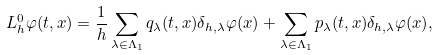Convert formula to latex. <formula><loc_0><loc_0><loc_500><loc_500>L _ { h } ^ { 0 } \varphi ( t , x ) = \frac { 1 } { h } \sum _ { \lambda \in \Lambda _ { 1 } } q _ { \lambda } ( t , x ) \delta _ { h , \lambda } \varphi ( x ) + \sum _ { \lambda \in \Lambda _ { 1 } } p _ { \lambda } ( t , x ) \delta _ { h , \lambda } \varphi ( x ) ,</formula> 